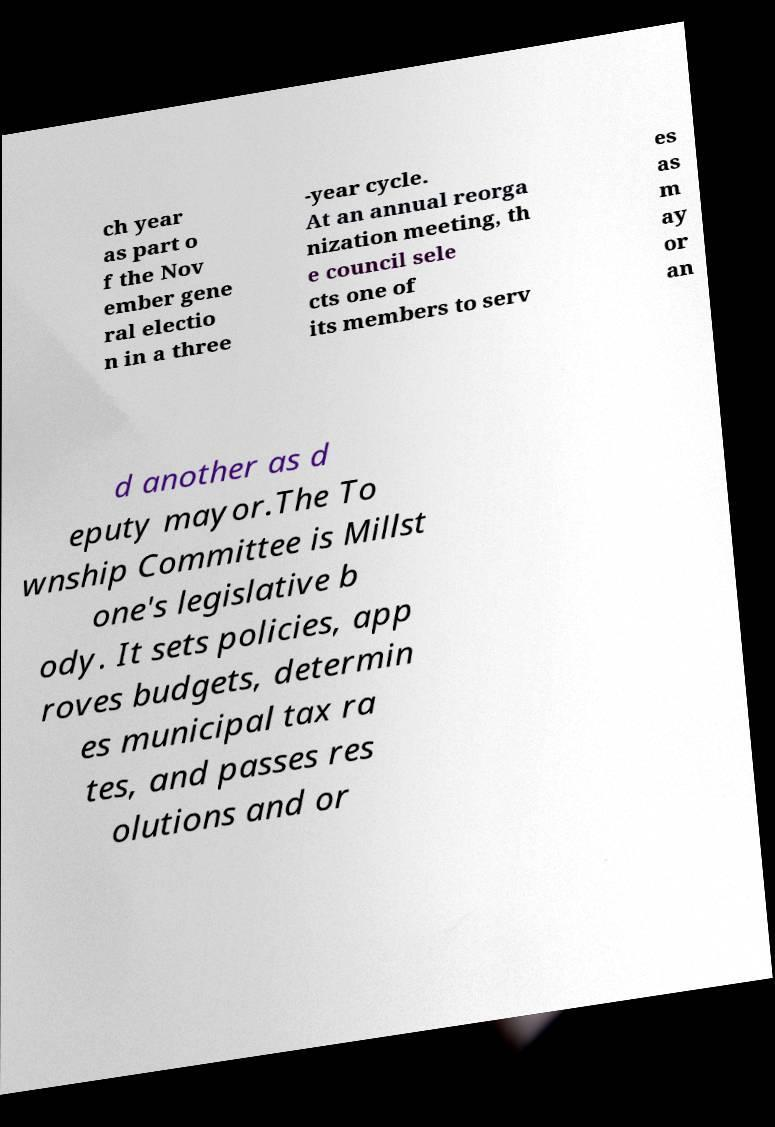Please read and relay the text visible in this image. What does it say? ch year as part o f the Nov ember gene ral electio n in a three -year cycle. At an annual reorga nization meeting, th e council sele cts one of its members to serv es as m ay or an d another as d eputy mayor.The To wnship Committee is Millst one's legislative b ody. It sets policies, app roves budgets, determin es municipal tax ra tes, and passes res olutions and or 